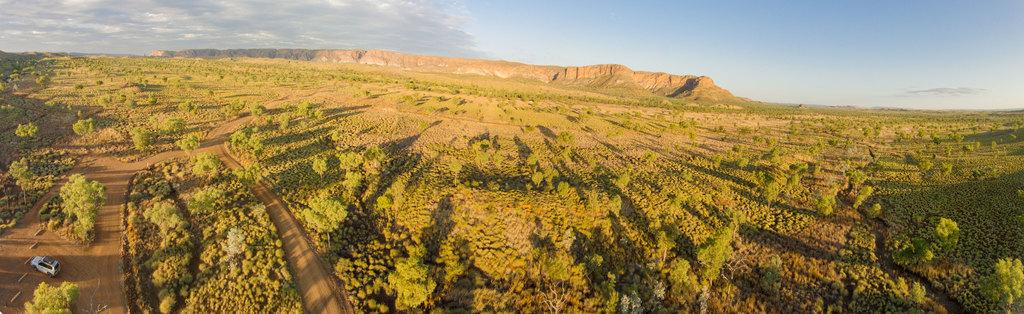What type of natural elements can be seen in the image? There are trees and plants in the image. What type of landscape feature is present in the image? There are hills in the image. What is visible in the background of the image? The sky is visible in the background of the image. Where is the vehicle located in the image? The vehicle is at the bottom left side of the image. What type of print can be seen on the cat in the image? There is no cat present in the image, so there is no print to observe. 